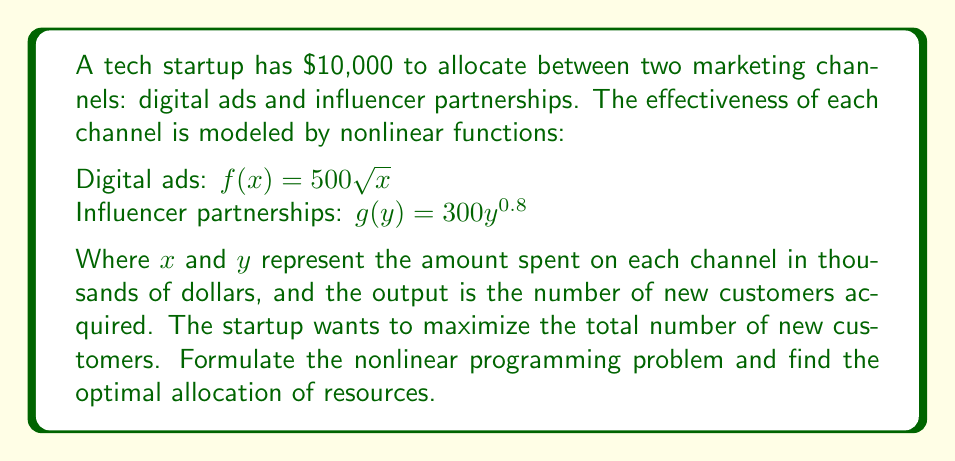Provide a solution to this math problem. To solve this problem, we'll follow these steps:

1) Formulate the nonlinear programming problem:
   Objective function: Maximize $Z = 500\sqrt{x} + 300y^{0.8}$
   Subject to: $x + y = 10$ (budget constraint)
               $x \geq 0, y \geq 0$ (non-negativity constraints)

2) Use the method of Lagrange multipliers:
   $L(x,y,\lambda) = 500\sqrt{x} + 300y^{0.8} + \lambda(10 - x - y)$

3) Take partial derivatives and set them to zero:
   $\frac{\partial L}{\partial x} = \frac{250}{\sqrt{x}} - \lambda = 0$
   $\frac{\partial L}{\partial y} = 240y^{-0.2} - \lambda = 0$
   $\frac{\partial L}{\partial \lambda} = 10 - x - y = 0$

4) From the first two equations:
   $\frac{250}{\sqrt{x}} = 240y^{-0.2}$

5) Simplify:
   $\frac{25}{24} = \frac{y^{0.2}}{\sqrt{x}}$
   $(\frac{25}{24})^5 = \frac{y}{x^{2.5}}$
   $y = (\frac{25}{24})^5 \cdot x^{2.5}$

6) Substitute into the budget constraint:
   $x + (\frac{25}{24})^5 \cdot x^{2.5} = 10$

7) Solve numerically (using a computer or calculator):
   $x \approx 5.95$
   $y \approx 4.05$

8) Verify the solution satisfies the constraints and is optimal.
Answer: Optimal allocation: $5,950 on digital ads, $4,050 on influencer partnerships 